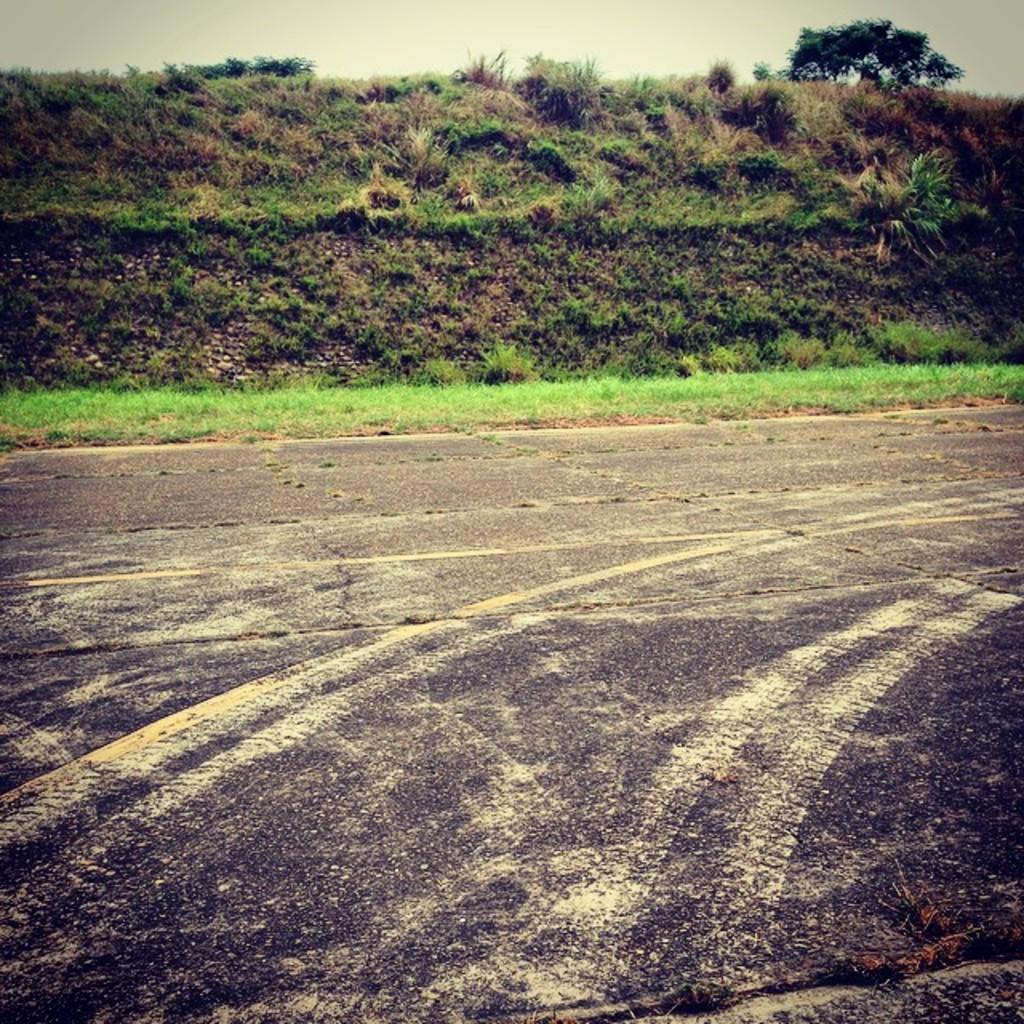Can you describe this image briefly? In the picture I can see the grass, plants and a tree. In the background I can see the sky. 